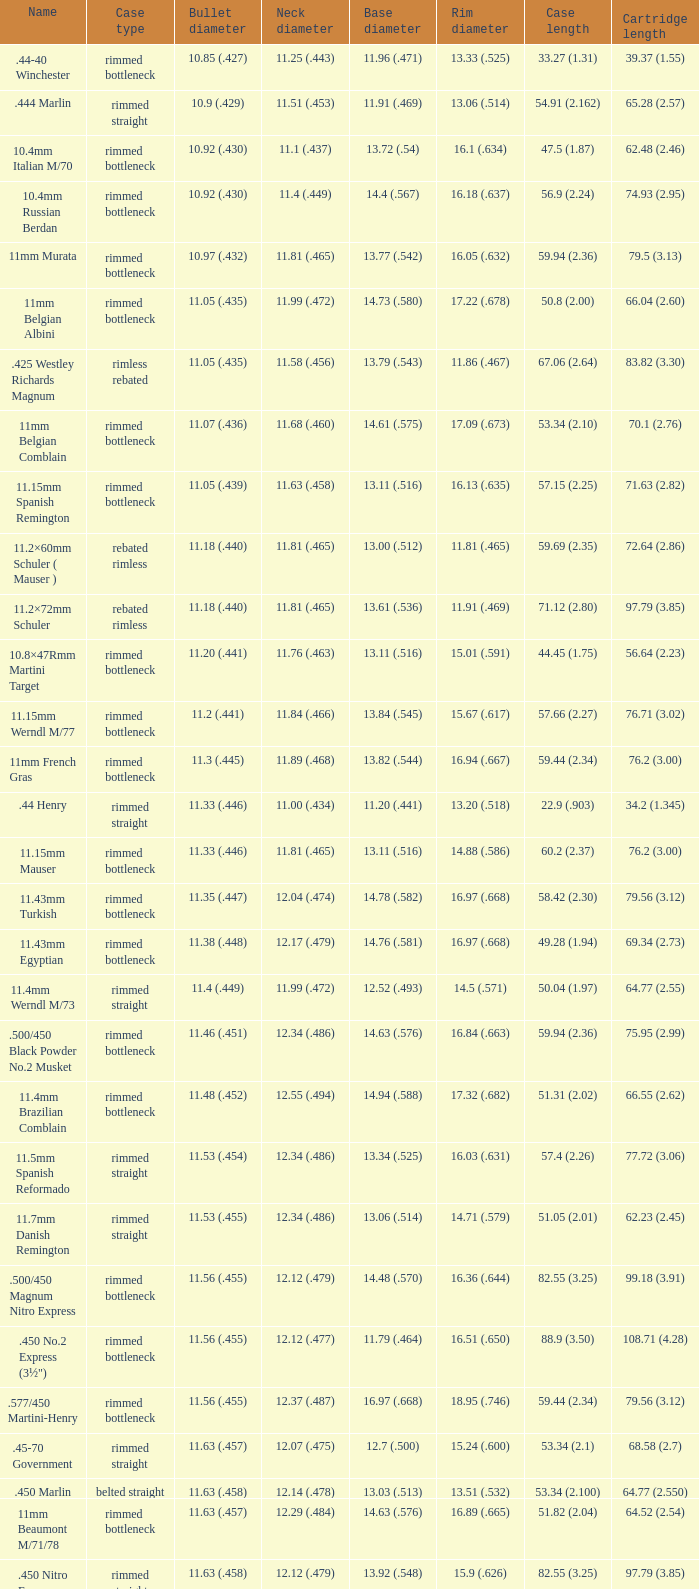Which case style possesses a base diameter of 1 Belted straight. 